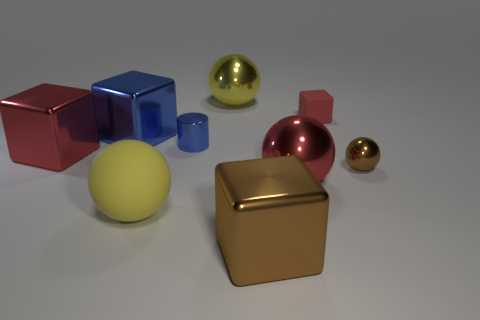What number of big yellow matte objects are there? 1 